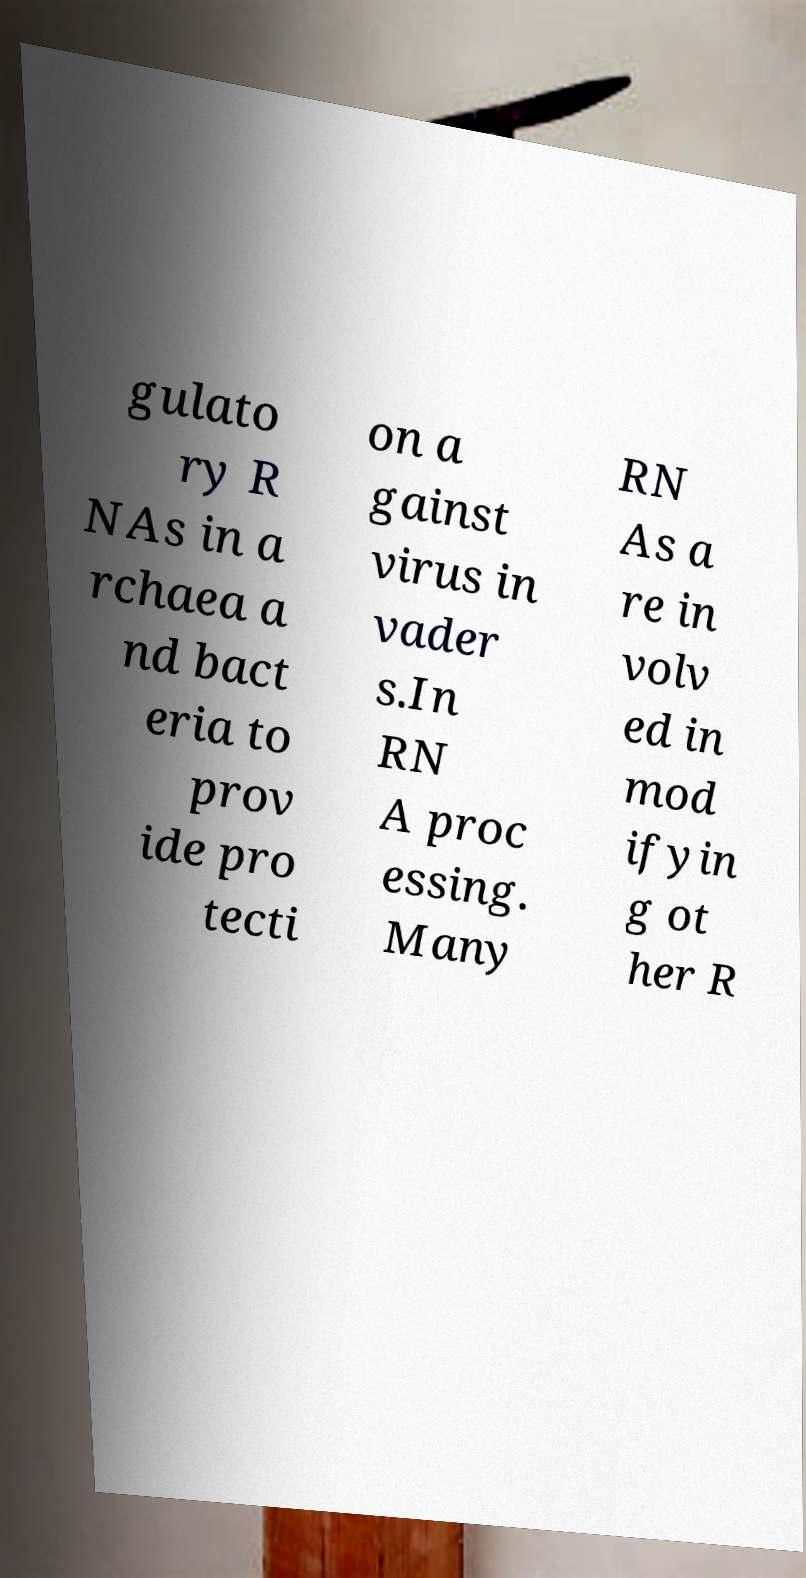For documentation purposes, I need the text within this image transcribed. Could you provide that? gulato ry R NAs in a rchaea a nd bact eria to prov ide pro tecti on a gainst virus in vader s.In RN A proc essing. Many RN As a re in volv ed in mod ifyin g ot her R 